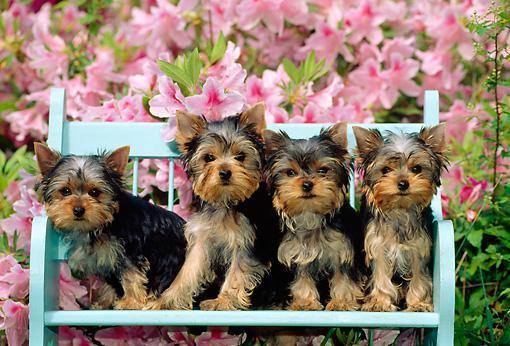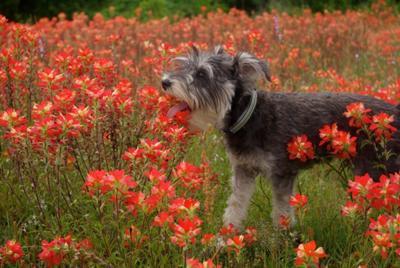The first image is the image on the left, the second image is the image on the right. Given the left and right images, does the statement "There are at most two dogs." hold true? Answer yes or no. No. The first image is the image on the left, the second image is the image on the right. Considering the images on both sides, is "An image contains at least three dogs." valid? Answer yes or no. Yes. 